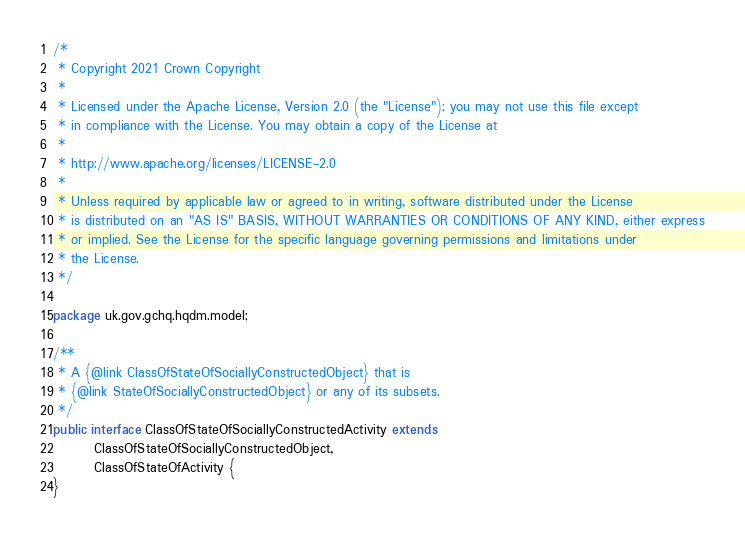<code> <loc_0><loc_0><loc_500><loc_500><_Java_>/*
 * Copyright 2021 Crown Copyright
 *
 * Licensed under the Apache License, Version 2.0 (the "License"); you may not use this file except
 * in compliance with the License. You may obtain a copy of the License at
 *
 * http://www.apache.org/licenses/LICENSE-2.0
 *
 * Unless required by applicable law or agreed to in writing, software distributed under the License
 * is distributed on an "AS IS" BASIS, WITHOUT WARRANTIES OR CONDITIONS OF ANY KIND, either express
 * or implied. See the License for the specific language governing permissions and limitations under
 * the License.
 */

package uk.gov.gchq.hqdm.model;

/**
 * A {@link ClassOfStateOfSociallyConstructedObject} that is
 * {@link StateOfSociallyConstructedObject} or any of its subsets.
 */
public interface ClassOfStateOfSociallyConstructedActivity extends
        ClassOfStateOfSociallyConstructedObject,
        ClassOfStateOfActivity {
}
</code> 